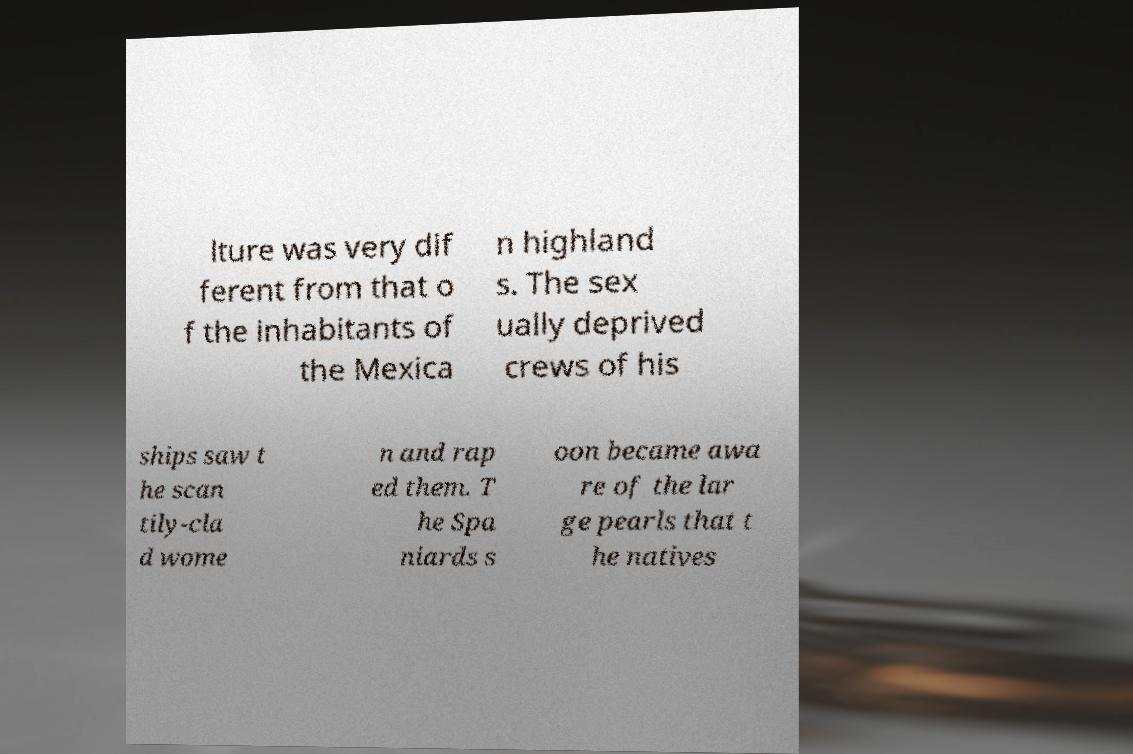For documentation purposes, I need the text within this image transcribed. Could you provide that? lture was very dif ferent from that o f the inhabitants of the Mexica n highland s. The sex ually deprived crews of his ships saw t he scan tily-cla d wome n and rap ed them. T he Spa niards s oon became awa re of the lar ge pearls that t he natives 